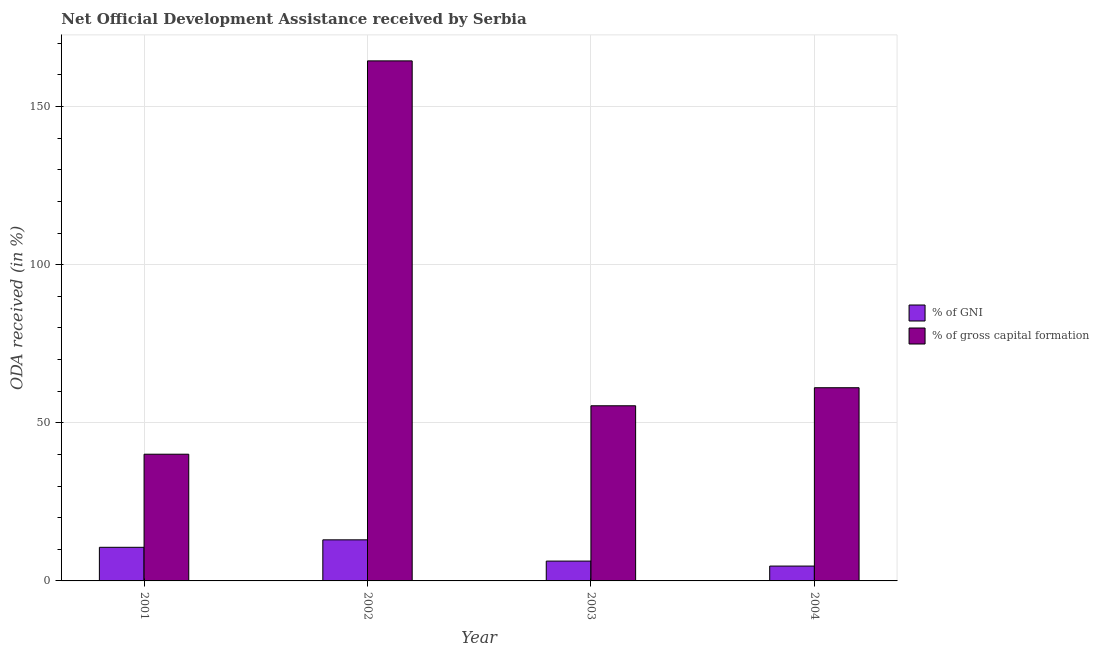How many different coloured bars are there?
Provide a short and direct response. 2. How many groups of bars are there?
Make the answer very short. 4. Are the number of bars per tick equal to the number of legend labels?
Your answer should be compact. Yes. Are the number of bars on each tick of the X-axis equal?
Offer a very short reply. Yes. How many bars are there on the 2nd tick from the left?
Give a very brief answer. 2. What is the oda received as percentage of gross capital formation in 2003?
Provide a short and direct response. 55.38. Across all years, what is the maximum oda received as percentage of gni?
Your answer should be compact. 12.99. Across all years, what is the minimum oda received as percentage of gni?
Offer a terse response. 4.7. In which year was the oda received as percentage of gni maximum?
Your answer should be very brief. 2002. What is the total oda received as percentage of gni in the graph?
Offer a very short reply. 34.58. What is the difference between the oda received as percentage of gni in 2001 and that in 2004?
Offer a terse response. 5.93. What is the difference between the oda received as percentage of gross capital formation in 2001 and the oda received as percentage of gni in 2003?
Ensure brevity in your answer.  -15.31. What is the average oda received as percentage of gni per year?
Offer a terse response. 8.65. In the year 2003, what is the difference between the oda received as percentage of gni and oda received as percentage of gross capital formation?
Your answer should be very brief. 0. In how many years, is the oda received as percentage of gross capital formation greater than 70 %?
Offer a very short reply. 1. What is the ratio of the oda received as percentage of gni in 2002 to that in 2004?
Your response must be concise. 2.77. Is the oda received as percentage of gni in 2002 less than that in 2003?
Give a very brief answer. No. What is the difference between the highest and the second highest oda received as percentage of gni?
Provide a succinct answer. 2.36. What is the difference between the highest and the lowest oda received as percentage of gross capital formation?
Provide a short and direct response. 124.36. In how many years, is the oda received as percentage of gross capital formation greater than the average oda received as percentage of gross capital formation taken over all years?
Offer a terse response. 1. Is the sum of the oda received as percentage of gni in 2002 and 2003 greater than the maximum oda received as percentage of gross capital formation across all years?
Provide a succinct answer. Yes. What does the 1st bar from the left in 2004 represents?
Provide a succinct answer. % of GNI. What does the 1st bar from the right in 2001 represents?
Offer a very short reply. % of gross capital formation. How many years are there in the graph?
Your response must be concise. 4. Does the graph contain grids?
Your answer should be compact. Yes. Where does the legend appear in the graph?
Your answer should be compact. Center right. How many legend labels are there?
Ensure brevity in your answer.  2. What is the title of the graph?
Your answer should be very brief. Net Official Development Assistance received by Serbia. What is the label or title of the X-axis?
Your answer should be very brief. Year. What is the label or title of the Y-axis?
Your answer should be very brief. ODA received (in %). What is the ODA received (in %) in % of GNI in 2001?
Your response must be concise. 10.63. What is the ODA received (in %) in % of gross capital formation in 2001?
Provide a short and direct response. 40.06. What is the ODA received (in %) of % of GNI in 2002?
Make the answer very short. 12.99. What is the ODA received (in %) in % of gross capital formation in 2002?
Provide a succinct answer. 164.42. What is the ODA received (in %) in % of GNI in 2003?
Make the answer very short. 6.27. What is the ODA received (in %) of % of gross capital formation in 2003?
Ensure brevity in your answer.  55.38. What is the ODA received (in %) in % of GNI in 2004?
Provide a short and direct response. 4.7. What is the ODA received (in %) of % of gross capital formation in 2004?
Your answer should be very brief. 61.08. Across all years, what is the maximum ODA received (in %) in % of GNI?
Provide a short and direct response. 12.99. Across all years, what is the maximum ODA received (in %) in % of gross capital formation?
Offer a very short reply. 164.42. Across all years, what is the minimum ODA received (in %) in % of GNI?
Keep it short and to the point. 4.7. Across all years, what is the minimum ODA received (in %) in % of gross capital formation?
Keep it short and to the point. 40.06. What is the total ODA received (in %) in % of GNI in the graph?
Offer a very short reply. 34.58. What is the total ODA received (in %) of % of gross capital formation in the graph?
Your answer should be very brief. 320.95. What is the difference between the ODA received (in %) in % of GNI in 2001 and that in 2002?
Offer a terse response. -2.36. What is the difference between the ODA received (in %) of % of gross capital formation in 2001 and that in 2002?
Give a very brief answer. -124.36. What is the difference between the ODA received (in %) of % of GNI in 2001 and that in 2003?
Keep it short and to the point. 4.36. What is the difference between the ODA received (in %) of % of gross capital formation in 2001 and that in 2003?
Your answer should be very brief. -15.31. What is the difference between the ODA received (in %) of % of GNI in 2001 and that in 2004?
Provide a short and direct response. 5.93. What is the difference between the ODA received (in %) of % of gross capital formation in 2001 and that in 2004?
Keep it short and to the point. -21.02. What is the difference between the ODA received (in %) in % of GNI in 2002 and that in 2003?
Your response must be concise. 6.72. What is the difference between the ODA received (in %) in % of gross capital formation in 2002 and that in 2003?
Provide a succinct answer. 109.05. What is the difference between the ODA received (in %) in % of GNI in 2002 and that in 2004?
Offer a very short reply. 8.29. What is the difference between the ODA received (in %) of % of gross capital formation in 2002 and that in 2004?
Your answer should be compact. 103.34. What is the difference between the ODA received (in %) in % of GNI in 2003 and that in 2004?
Offer a very short reply. 1.57. What is the difference between the ODA received (in %) of % of gross capital formation in 2003 and that in 2004?
Provide a succinct answer. -5.71. What is the difference between the ODA received (in %) in % of GNI in 2001 and the ODA received (in %) in % of gross capital formation in 2002?
Provide a succinct answer. -153.8. What is the difference between the ODA received (in %) in % of GNI in 2001 and the ODA received (in %) in % of gross capital formation in 2003?
Your answer should be very brief. -44.75. What is the difference between the ODA received (in %) of % of GNI in 2001 and the ODA received (in %) of % of gross capital formation in 2004?
Make the answer very short. -50.46. What is the difference between the ODA received (in %) in % of GNI in 2002 and the ODA received (in %) in % of gross capital formation in 2003?
Provide a short and direct response. -42.39. What is the difference between the ODA received (in %) in % of GNI in 2002 and the ODA received (in %) in % of gross capital formation in 2004?
Ensure brevity in your answer.  -48.09. What is the difference between the ODA received (in %) of % of GNI in 2003 and the ODA received (in %) of % of gross capital formation in 2004?
Keep it short and to the point. -54.81. What is the average ODA received (in %) in % of GNI per year?
Provide a short and direct response. 8.65. What is the average ODA received (in %) of % of gross capital formation per year?
Your response must be concise. 80.24. In the year 2001, what is the difference between the ODA received (in %) in % of GNI and ODA received (in %) in % of gross capital formation?
Make the answer very short. -29.44. In the year 2002, what is the difference between the ODA received (in %) of % of GNI and ODA received (in %) of % of gross capital formation?
Your response must be concise. -151.43. In the year 2003, what is the difference between the ODA received (in %) in % of GNI and ODA received (in %) in % of gross capital formation?
Give a very brief answer. -49.1. In the year 2004, what is the difference between the ODA received (in %) of % of GNI and ODA received (in %) of % of gross capital formation?
Ensure brevity in your answer.  -56.39. What is the ratio of the ODA received (in %) of % of GNI in 2001 to that in 2002?
Make the answer very short. 0.82. What is the ratio of the ODA received (in %) in % of gross capital formation in 2001 to that in 2002?
Your answer should be compact. 0.24. What is the ratio of the ODA received (in %) of % of GNI in 2001 to that in 2003?
Keep it short and to the point. 1.69. What is the ratio of the ODA received (in %) of % of gross capital formation in 2001 to that in 2003?
Offer a very short reply. 0.72. What is the ratio of the ODA received (in %) of % of GNI in 2001 to that in 2004?
Give a very brief answer. 2.26. What is the ratio of the ODA received (in %) in % of gross capital formation in 2001 to that in 2004?
Your answer should be compact. 0.66. What is the ratio of the ODA received (in %) in % of GNI in 2002 to that in 2003?
Offer a terse response. 2.07. What is the ratio of the ODA received (in %) of % of gross capital formation in 2002 to that in 2003?
Provide a short and direct response. 2.97. What is the ratio of the ODA received (in %) of % of GNI in 2002 to that in 2004?
Keep it short and to the point. 2.77. What is the ratio of the ODA received (in %) of % of gross capital formation in 2002 to that in 2004?
Provide a short and direct response. 2.69. What is the ratio of the ODA received (in %) in % of GNI in 2003 to that in 2004?
Your answer should be very brief. 1.33. What is the ratio of the ODA received (in %) in % of gross capital formation in 2003 to that in 2004?
Provide a succinct answer. 0.91. What is the difference between the highest and the second highest ODA received (in %) in % of GNI?
Provide a short and direct response. 2.36. What is the difference between the highest and the second highest ODA received (in %) in % of gross capital formation?
Your answer should be compact. 103.34. What is the difference between the highest and the lowest ODA received (in %) in % of GNI?
Offer a very short reply. 8.29. What is the difference between the highest and the lowest ODA received (in %) in % of gross capital formation?
Offer a very short reply. 124.36. 